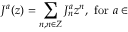<formula> <loc_0><loc_0><loc_500><loc_500>J ^ { a } ( z ) = \sum _ { n , n \in Z } J _ { n } ^ { a } z ^ { n } , f o r a \in</formula> 